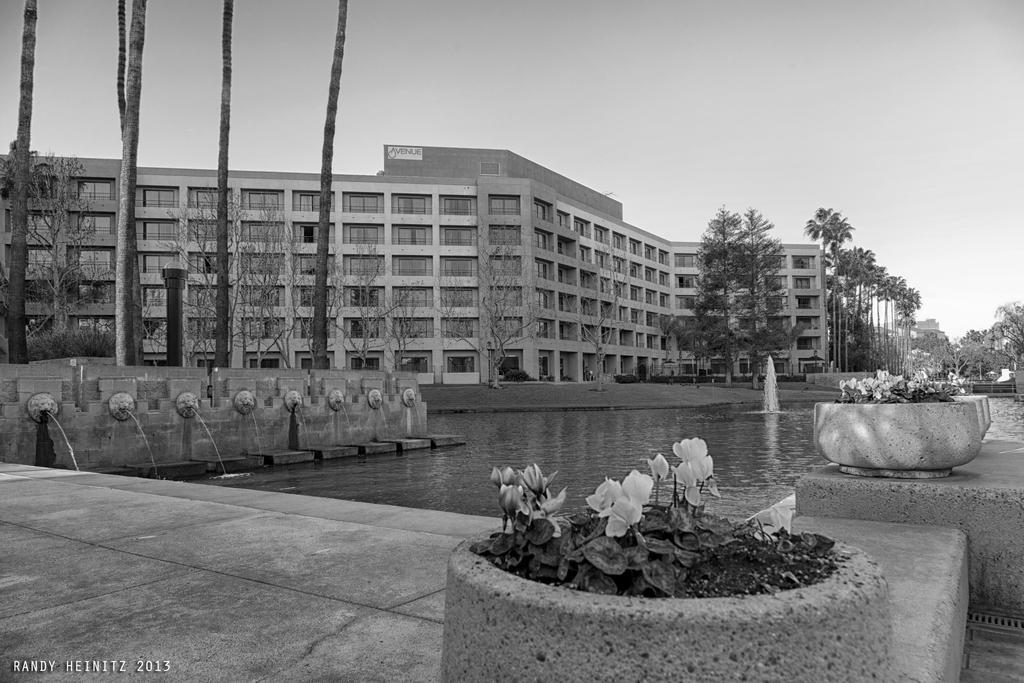Describe this image in one or two sentences. In this image I can see number of flowers on the right side. In the background I can see water, number of trees, a pole and a building. I can also see a board on the top of the building and on the bottom left side of this image I can see a watermark. I can also see this image is black and white in color. 